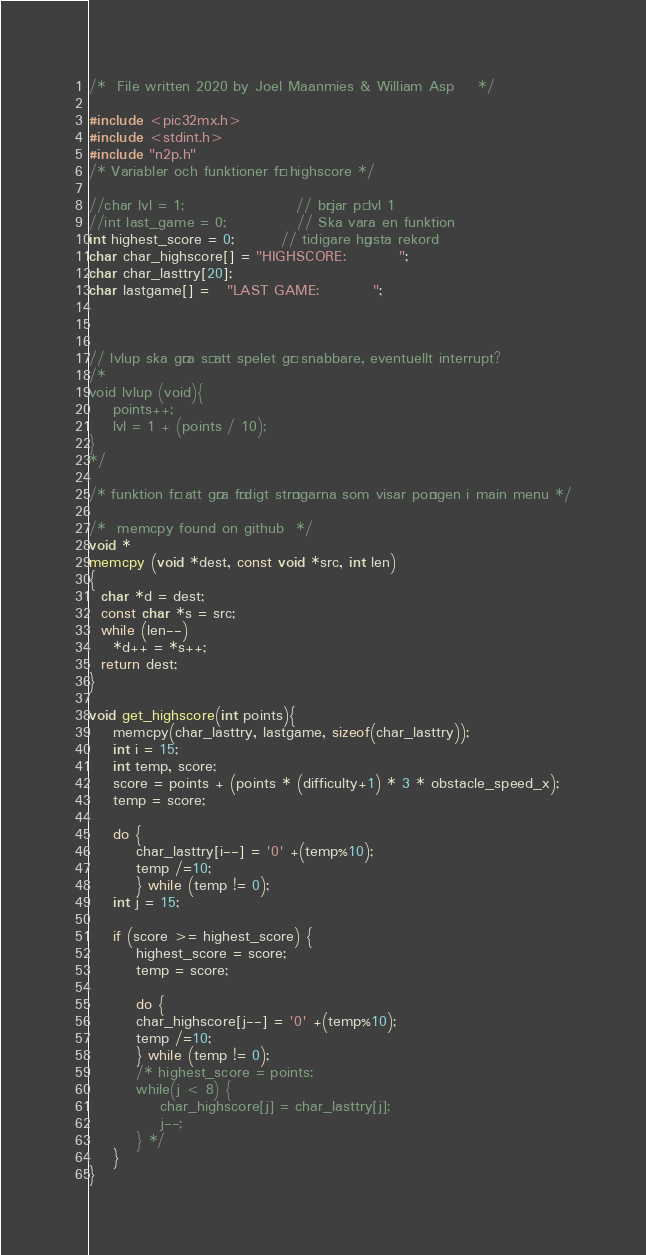Convert code to text. <code><loc_0><loc_0><loc_500><loc_500><_C_>/*	File written 2020 by Joel Maanmies & William Asp	*/

#include <pic32mx.h>
#include <stdint.h>
#include "n2p.h"
/* Variabler och funktioner för highscore */

//char lvl = 1;                   // börjar på lvl 1
//int last_game = 0;            // Ska vara en funktion
int highest_score = 0;        // tidigare högsta rekord
char char_highscore[] = "HIGHSCORE:         ";
char char_lasttry[20]; 
char lastgame[] =   "LAST GAME:         ";



// lvlup ska göra så att spelet går snabbare, eventuellt interrupt?
/*
void lvlup (void){
    points++;
    lvl = 1 + (points / 10);
}
*/

/* funktion för att göra färdigt strängarna som visar poängen i main menu */

/*  memcpy found on github  */
void *
memcpy (void *dest, const void *src, int len)
{
  char *d = dest;
  const char *s = src;
  while (len--)
    *d++ = *s++;
  return dest;
}

void get_highscore(int points){
    memcpy(char_lasttry, lastgame, sizeof(char_lasttry));
    int i = 15;
    int temp, score;
    score = points + (points * (difficulty+1) * 3 * obstacle_speed_x);
    temp = score;

    do {
        char_lasttry[i--] = '0' +(temp%10);
        temp /=10;
        } while (temp != 0);                   
    int j = 15;

    if (score >= highest_score) {
        highest_score = score;
        temp = score;

        do {
        char_highscore[j--] = '0' +(temp%10);
        temp /=10;
        } while (temp != 0);
        /* highest_score = points;
        while(j < 8) {            
            char_highscore[j] = char_lasttry[j];
            j--;
        } */
    }
}</code> 